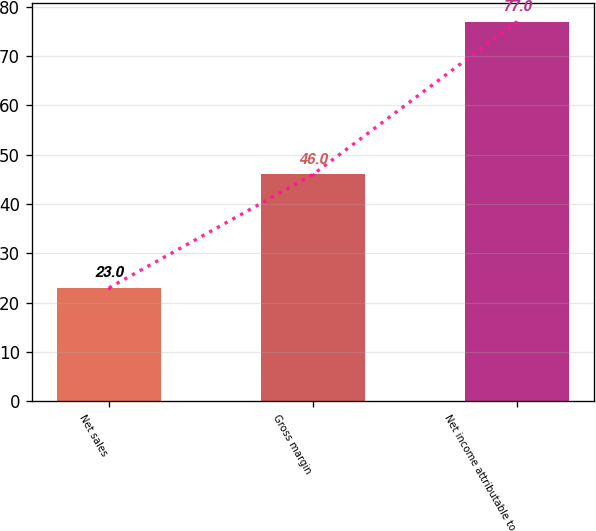Convert chart to OTSL. <chart><loc_0><loc_0><loc_500><loc_500><bar_chart><fcel>Net sales<fcel>Gross margin<fcel>Net income attributable to<nl><fcel>23<fcel>46<fcel>77<nl></chart> 